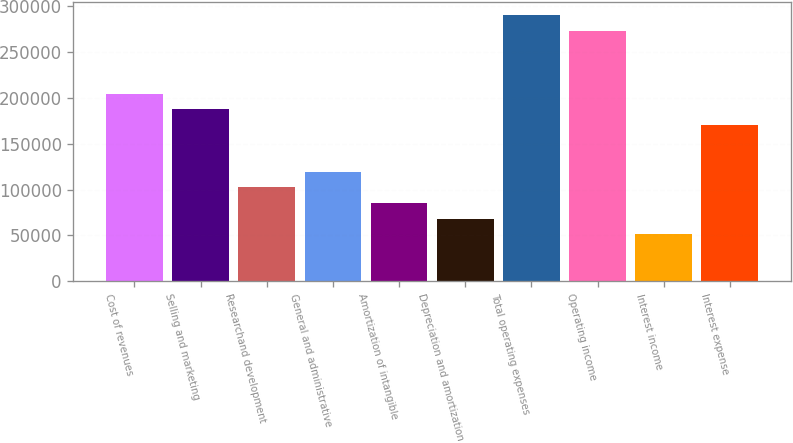Convert chart to OTSL. <chart><loc_0><loc_0><loc_500><loc_500><bar_chart><fcel>Cost of revenues<fcel>Selling and marketing<fcel>Researchand development<fcel>General and administrative<fcel>Amortization of intangible<fcel>Depreciation and amortization<fcel>Total operating expenses<fcel>Operating income<fcel>Interest income<fcel>Interest expense<nl><fcel>204726<fcel>187665<fcel>102363<fcel>119424<fcel>85302.9<fcel>68242.5<fcel>290028<fcel>272968<fcel>51182.1<fcel>170605<nl></chart> 